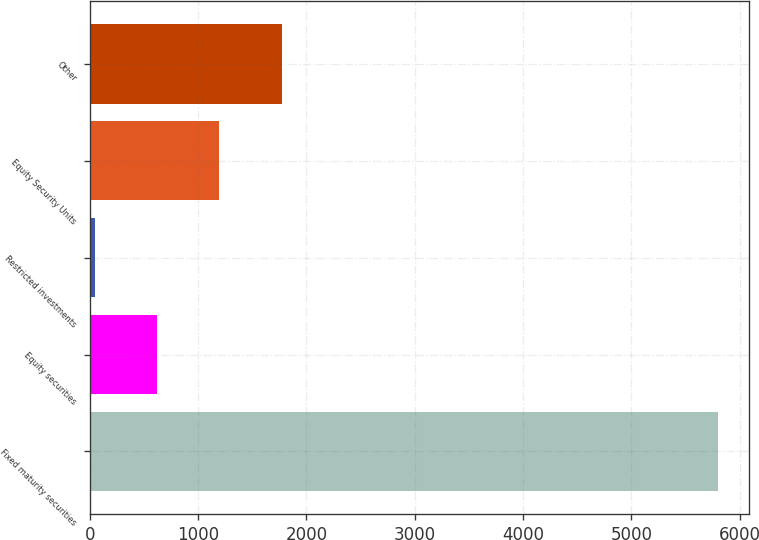Convert chart. <chart><loc_0><loc_0><loc_500><loc_500><bar_chart><fcel>Fixed maturity securities<fcel>Equity securities<fcel>Restricted investments<fcel>Equity Security Units<fcel>Other<nl><fcel>5797.4<fcel>623.3<fcel>48.4<fcel>1198.2<fcel>1773.1<nl></chart> 